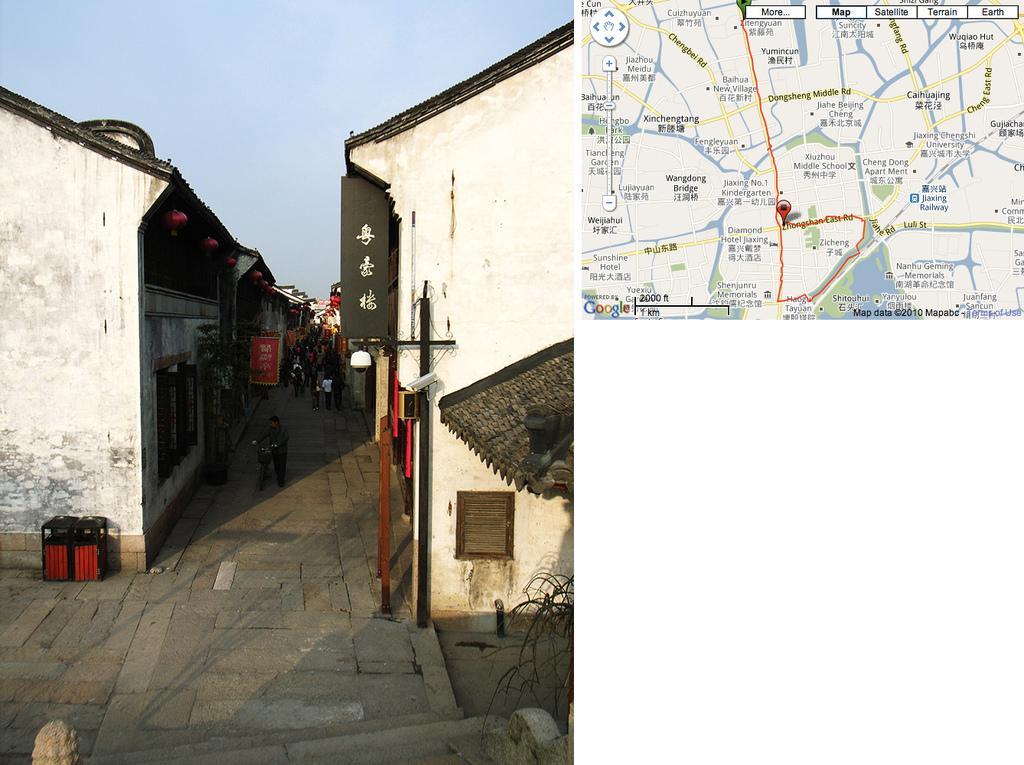In one or two sentences, can you explain what this image depicts? In the center of the image we can see a few people are standing and a few people are holding some objects. At the bottom of the image, we can see a solid structure, wall and branches. In the background, we can see the sky, buildings, sign boards, poles and a few other objects. At the top right side of the image, we can see a google map. 